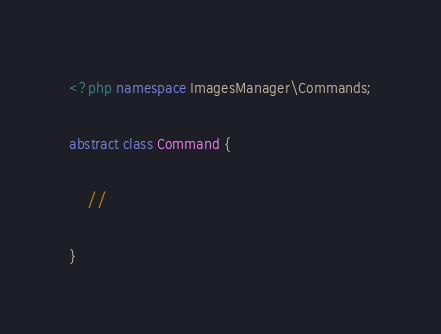Convert code to text. <code><loc_0><loc_0><loc_500><loc_500><_PHP_><?php namespace ImagesManager\Commands;

abstract class Command {

	//

}
</code> 